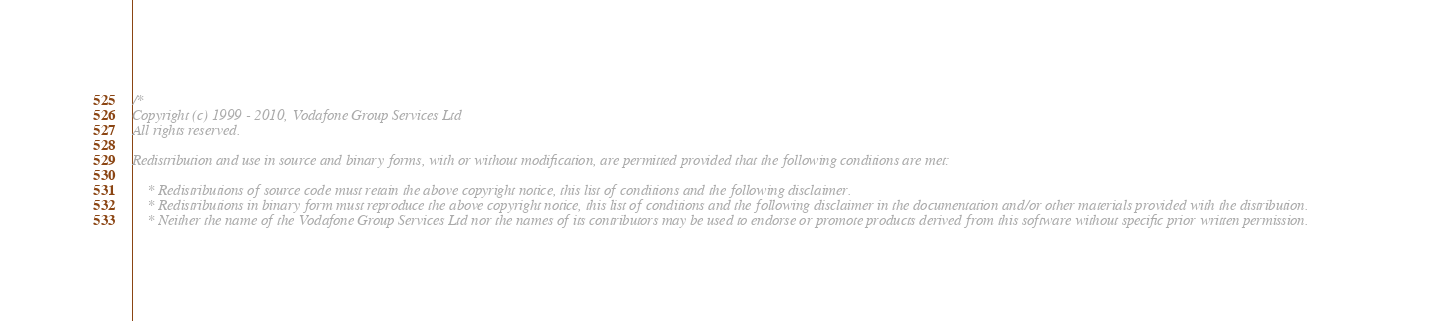<code> <loc_0><loc_0><loc_500><loc_500><_C++_>/*
Copyright (c) 1999 - 2010, Vodafone Group Services Ltd
All rights reserved.

Redistribution and use in source and binary forms, with or without modification, are permitted provided that the following conditions are met:

    * Redistributions of source code must retain the above copyright notice, this list of conditions and the following disclaimer.
    * Redistributions in binary form must reproduce the above copyright notice, this list of conditions and the following disclaimer in the documentation and/or other materials provided with the distribution.
    * Neither the name of the Vodafone Group Services Ltd nor the names of its contributors may be used to endorse or promote products derived from this software without specific prior written permission.
</code> 